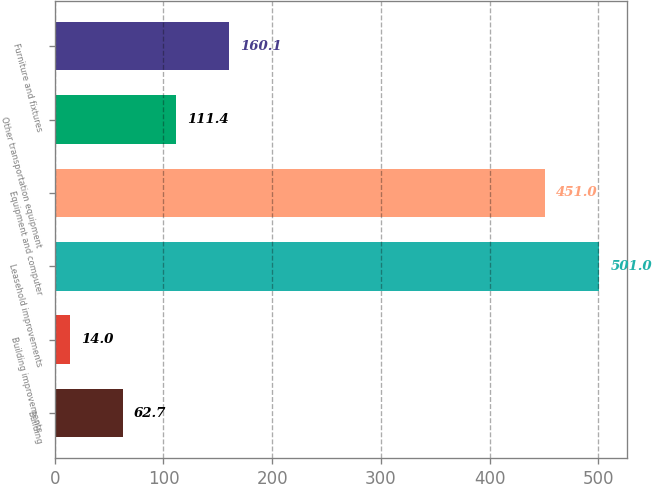Convert chart. <chart><loc_0><loc_0><loc_500><loc_500><bar_chart><fcel>Building<fcel>Building improvements<fcel>Leasehold improvements<fcel>Equipment and computer<fcel>Other transportation equipment<fcel>Furniture and fixtures<nl><fcel>62.7<fcel>14<fcel>501<fcel>451<fcel>111.4<fcel>160.1<nl></chart> 